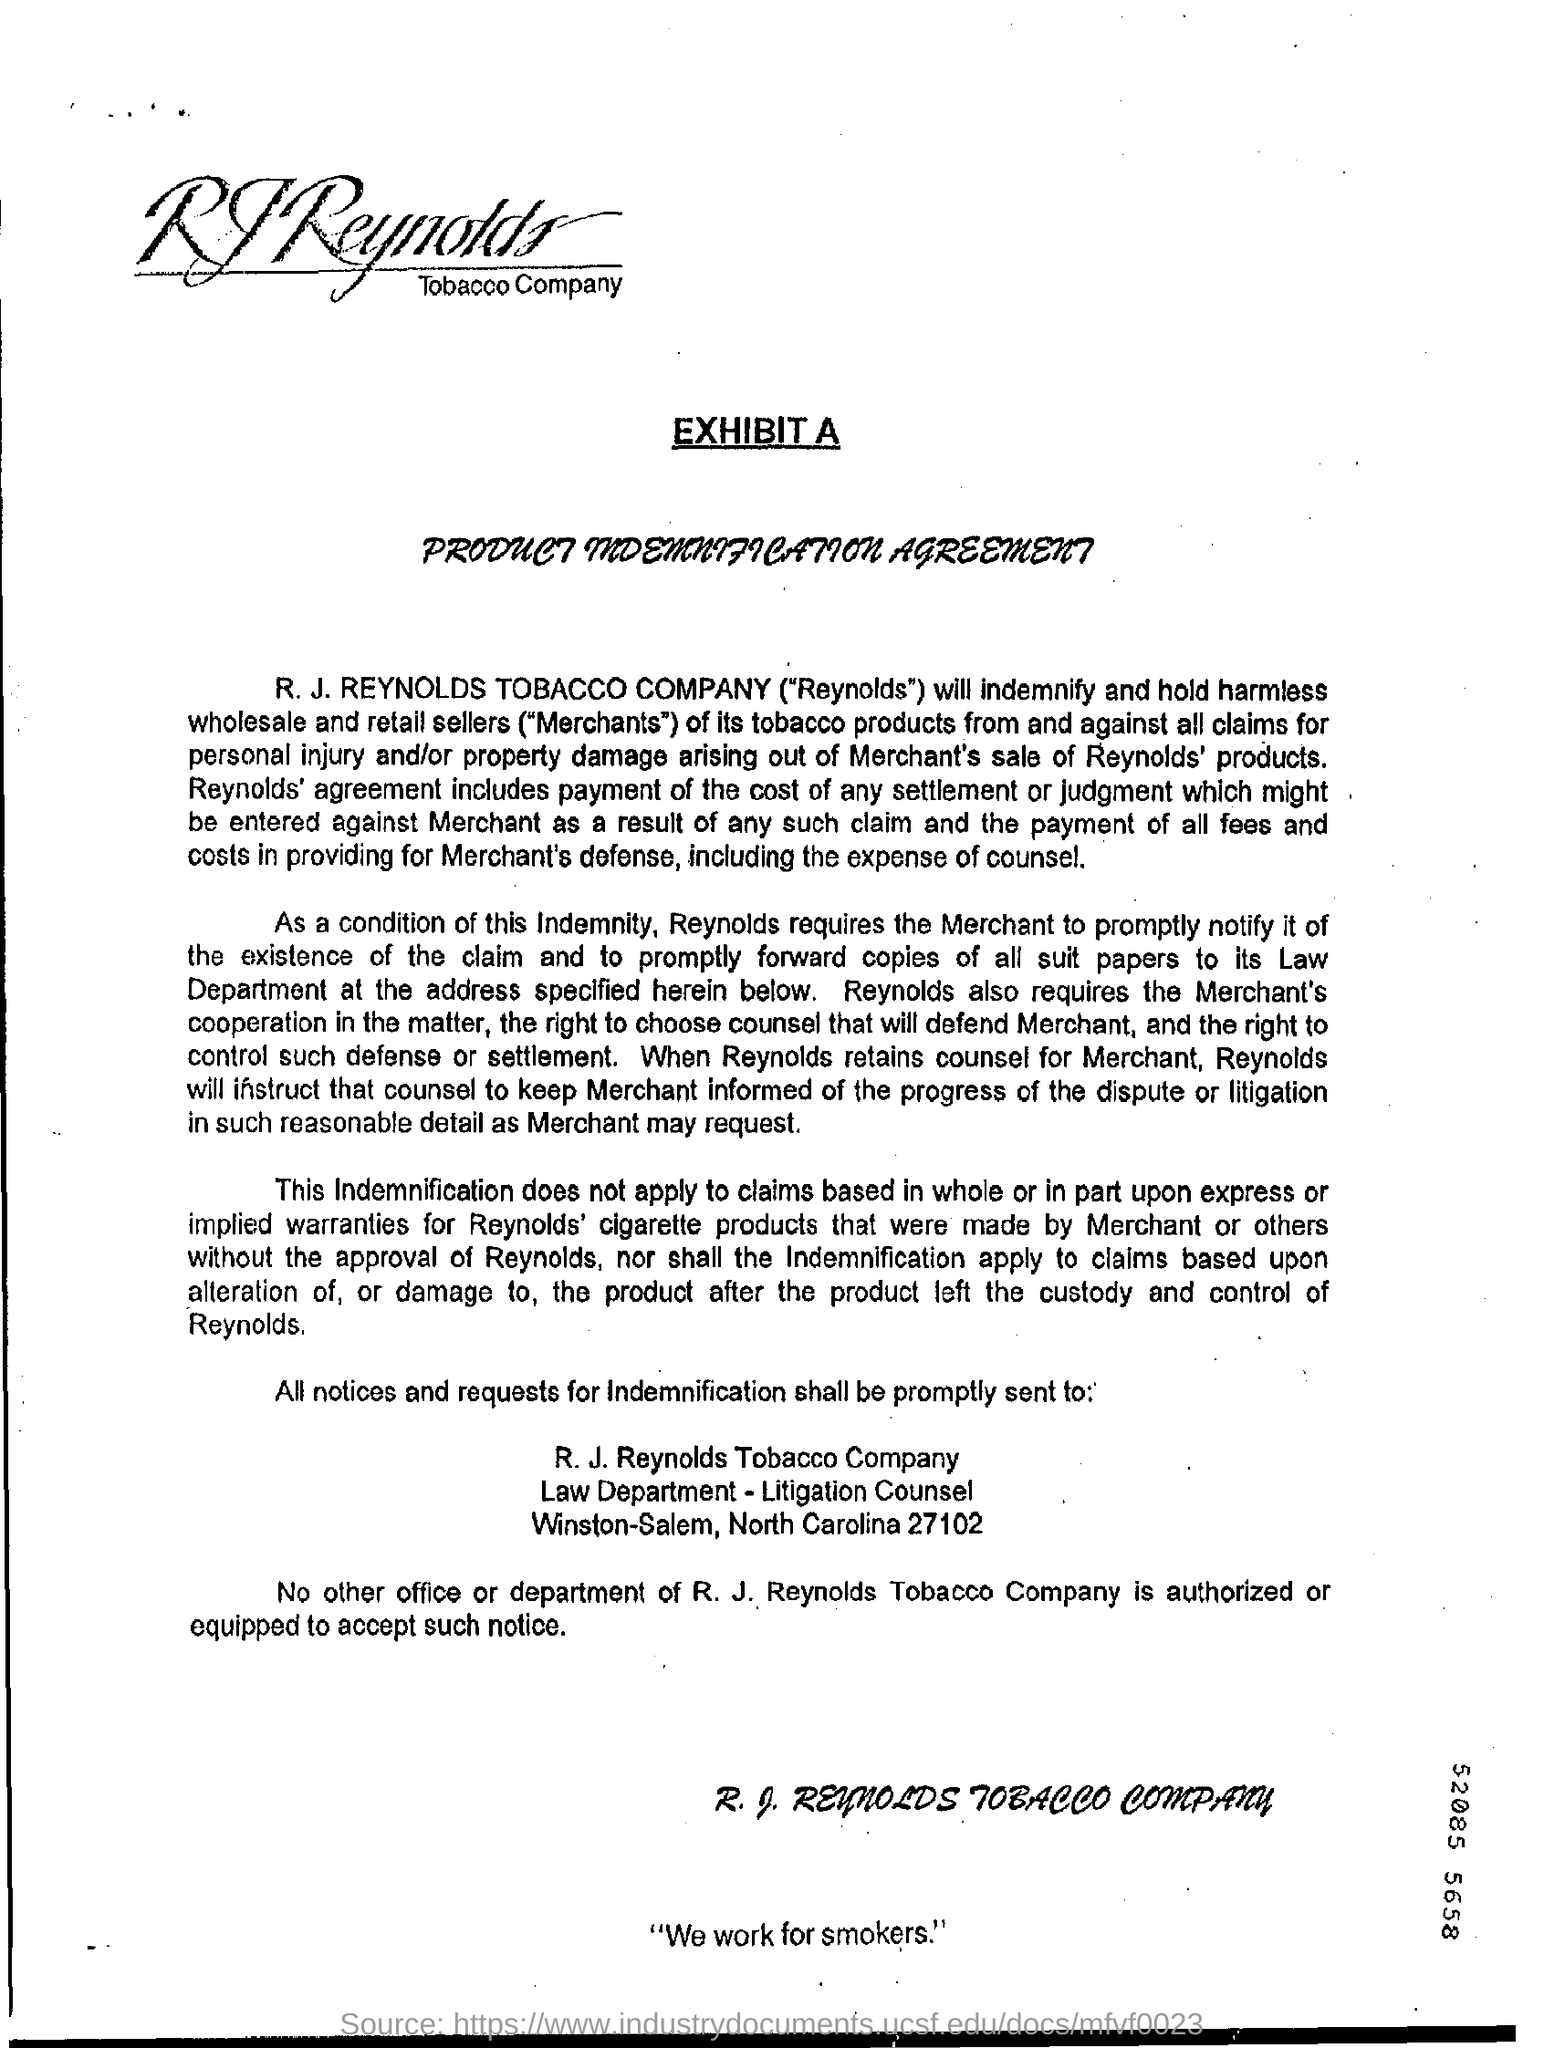What is the slogan written at the bottom of the document?
Offer a very short reply. "We work for smokers.". What is the 9 digits number mentioned?
Ensure brevity in your answer.  52085 5658. What is the sentence written at the ending of the page?
Give a very brief answer. "We work for smokers". 